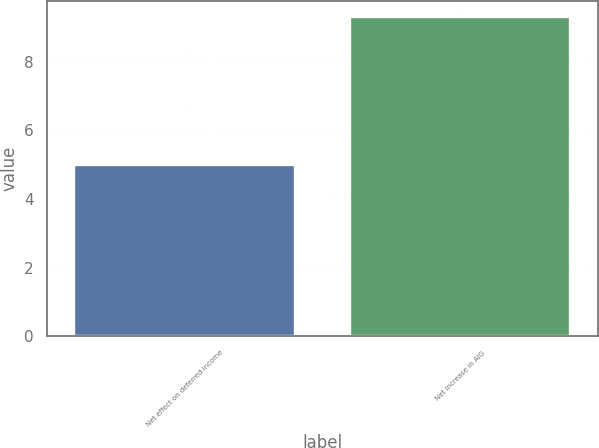Convert chart to OTSL. <chart><loc_0><loc_0><loc_500><loc_500><bar_chart><fcel>Net effect on deferred income<fcel>Net increase in AIG<nl><fcel>5<fcel>9.3<nl></chart> 